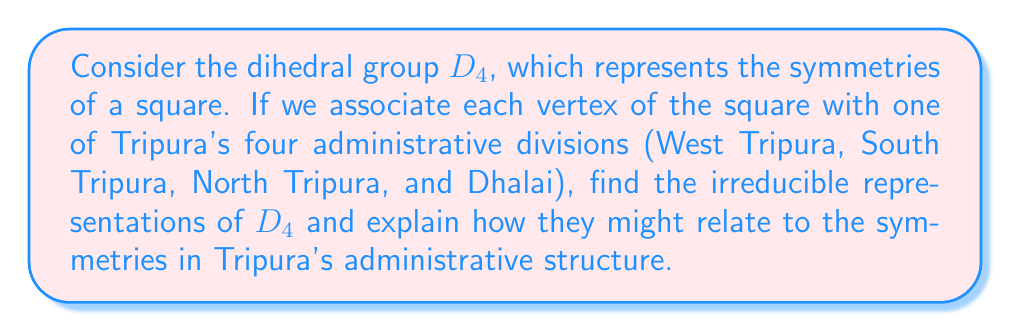Provide a solution to this math problem. To find the irreducible representations of $D_4$, we follow these steps:

1) First, recall that $D_4$ has 8 elements: 4 rotations (including identity) and 4 reflections.

2) The number of irreducible representations is equal to the number of conjugacy classes. $D_4$ has 5 conjugacy classes:
   - $\{e\}$ (identity)
   - $\{r^2\}$ (180° rotation)
   - $\{r, r^3\}$ (90° and 270° rotations)
   - $\{s, sr^2\}$ (reflections across diagonals)
   - $\{sr, sr^3\}$ (reflections across vertical and horizontal axes)

3) The sum of squares of dimensions of irreducible representations must equal the order of the group (8). Given 5 irreducible representations, the only possibility is: $1^2 + 1^2 + 1^2 + 1^2 + 2^2 = 8$.

4) Therefore, $D_4$ has four 1-dimensional representations and one 2-dimensional representation.

5) The 1-dimensional representations are:
   - Trivial representation: $\chi_1(g) = 1$ for all $g \in D_4$
   - Sign representation: $\chi_2(g) = 1$ for rotations, $-1$ for reflections
   - $\chi_3(g) = 1$ for $\{e, r^2, s, sr^2\}$, $-1$ otherwise
   - $\chi_4(g) = 1$ for $\{e, r^2, sr, sr^3\}$, $-1$ otherwise

6) The 2-dimensional representation $\rho$ can be given by:
   $$\rho(r) = \begin{pmatrix} 0 & -1 \\ 1 & 0 \end{pmatrix}, \quad
   \rho(s) = \begin{pmatrix} 1 & 0 \\ 0 & -1 \end{pmatrix}$$

Relating to Tripura's administrative divisions:
- The trivial representation ($\chi_1$) corresponds to treating all divisions equally.
- The sign representation ($\chi_2$) could represent a distinction between "central" (West and South Tripura) and "peripheral" (North Tripura and Dhalai) divisions.
- $\chi_3$ and $\chi_4$ could represent different pairings of the divisions.
- The 2-dimensional representation ($\rho$) allows for more complex relationships between the divisions, potentially reflecting geographical or political dynamics.
Answer: Four 1-dimensional representations ($\chi_1$, $\chi_2$, $\chi_3$, $\chi_4$) and one 2-dimensional representation ($\rho$) 